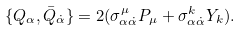Convert formula to latex. <formula><loc_0><loc_0><loc_500><loc_500>\{ Q _ { \alpha } , \bar { Q } _ { \dot { \alpha } } \} = 2 ( \sigma ^ { \mu } _ { \alpha \dot { \alpha } } P _ { \mu } + \sigma ^ { k } _ { \alpha \dot { \alpha } } Y _ { k } ) .</formula> 